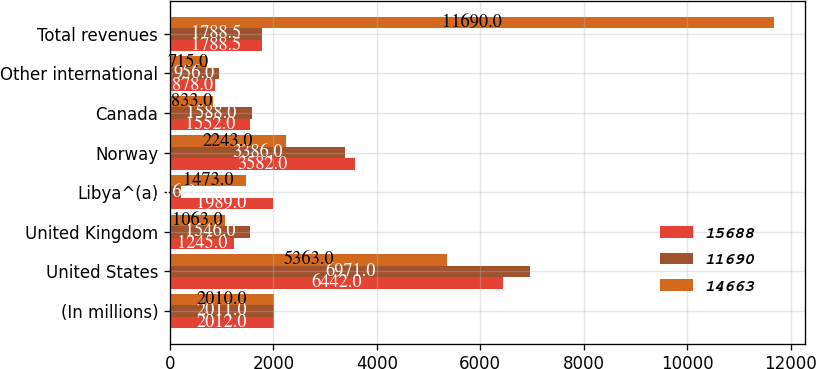Convert chart to OTSL. <chart><loc_0><loc_0><loc_500><loc_500><stacked_bar_chart><ecel><fcel>(In millions)<fcel>United States<fcel>United Kingdom<fcel>Libya^(a)<fcel>Norway<fcel>Canada<fcel>Other international<fcel>Total revenues<nl><fcel>15688<fcel>2012<fcel>6442<fcel>1245<fcel>1989<fcel>3582<fcel>1552<fcel>878<fcel>1788.5<nl><fcel>11690<fcel>2011<fcel>6971<fcel>1546<fcel>216<fcel>3386<fcel>1588<fcel>956<fcel>1788.5<nl><fcel>14663<fcel>2010<fcel>5363<fcel>1063<fcel>1473<fcel>2243<fcel>833<fcel>715<fcel>11690<nl></chart> 